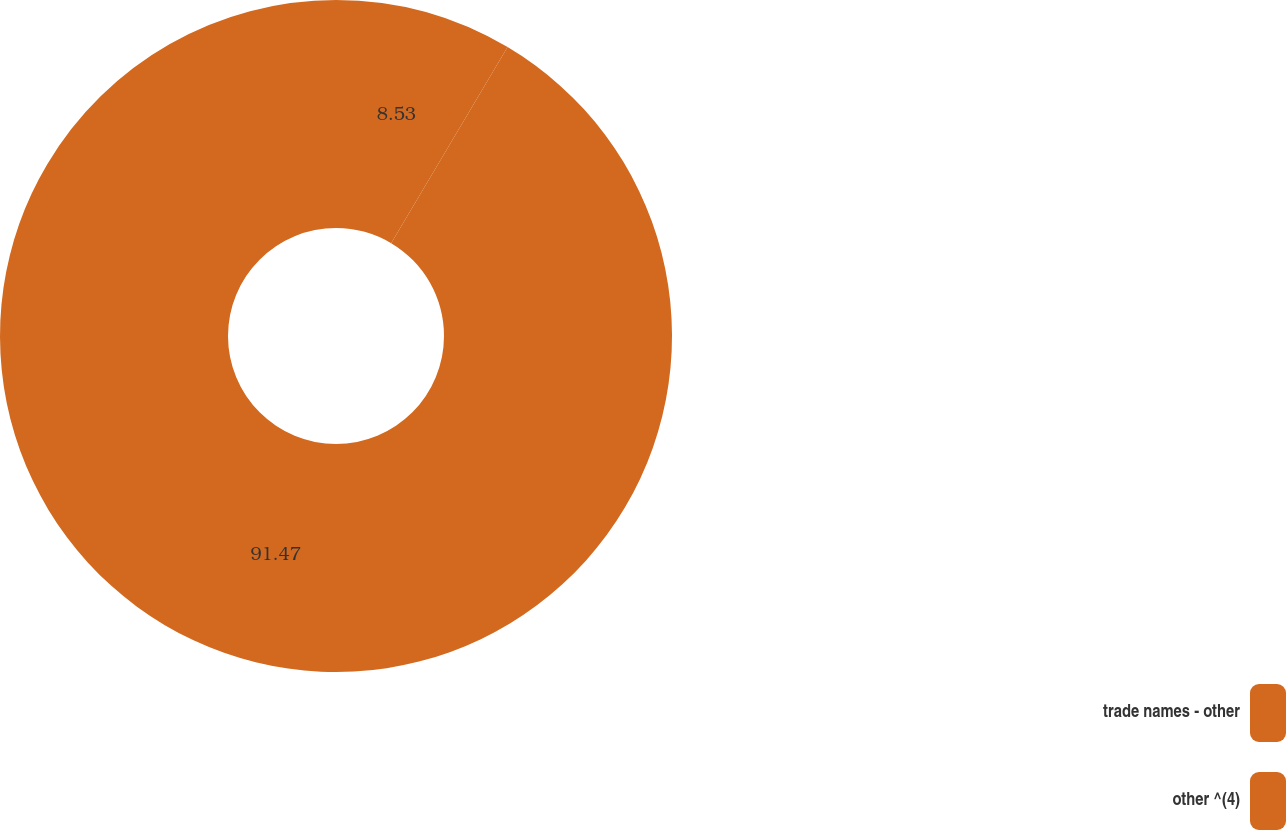Convert chart. <chart><loc_0><loc_0><loc_500><loc_500><pie_chart><fcel>trade names - other<fcel>other ^(4)<nl><fcel>8.53%<fcel>91.47%<nl></chart> 